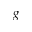<formula> <loc_0><loc_0><loc_500><loc_500>g</formula> 